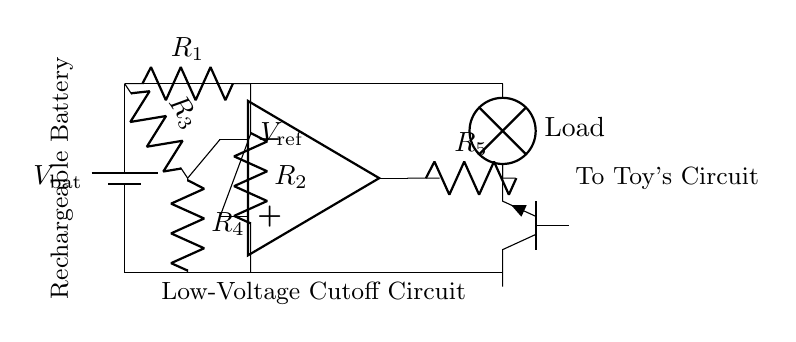What is the type of battery used? The diagram shows a rechargeable battery symbol, indicating it is a rechargeable battery type.
Answer: rechargeable battery What is the function of the op-amp? The op-amp in the circuit acts as a comparator, comparing the battery voltage to a reference voltage to determine cutoff conditions.
Answer: comparator What does R1 and R2 create in this circuit? R1 and R2 form a voltage divider that sets the reference voltage for the op-amp's positive input.
Answer: voltage divider What component is used for the low-voltage cutoff? The circuit utilizes a transistor (npn) as a switch for the low-voltage cutoff mechanism to disconnect the load from the battery.
Answer: npn What is the purpose of R5 in the circuit? R5 is used to limit the output current flowing through the transistor (npn), ensuring safe operation without damaging the components.
Answer: current limiter When does the load turn off? The load turns off when the battery voltage drops below the reference voltage set by R1 and R2.
Answer: below reference voltage What happens to the load when the voltage is sufficient? When the battery voltage is sufficient, the op-amp output allows current to flow, keeping the load powered.
Answer: load powered 